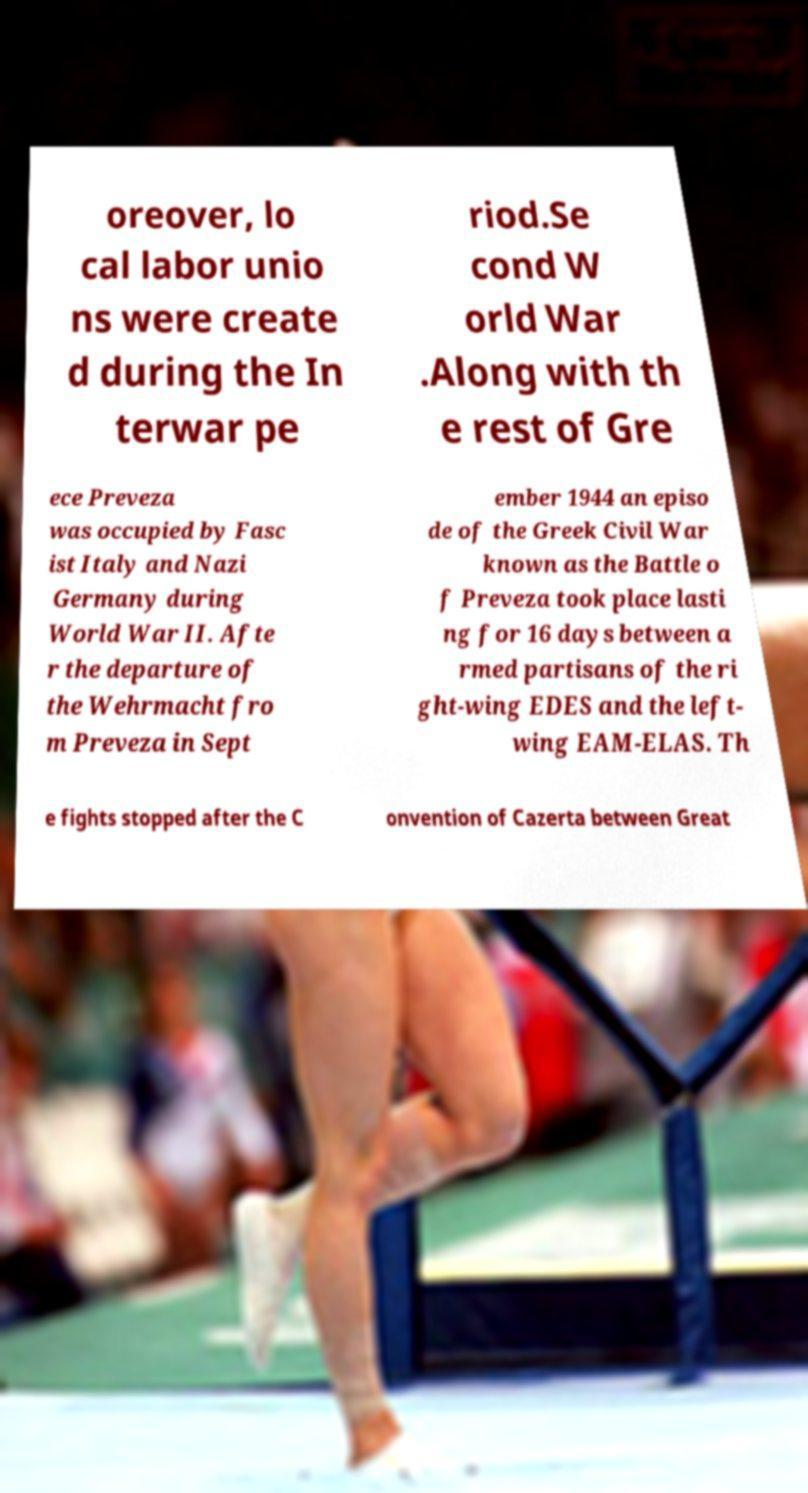Can you read and provide the text displayed in the image?This photo seems to have some interesting text. Can you extract and type it out for me? oreover, lo cal labor unio ns were create d during the In terwar pe riod.Se cond W orld War .Along with th e rest of Gre ece Preveza was occupied by Fasc ist Italy and Nazi Germany during World War II. Afte r the departure of the Wehrmacht fro m Preveza in Sept ember 1944 an episo de of the Greek Civil War known as the Battle o f Preveza took place lasti ng for 16 days between a rmed partisans of the ri ght-wing EDES and the left- wing EAM-ELAS. Th e fights stopped after the C onvention of Cazerta between Great 